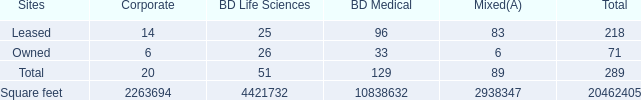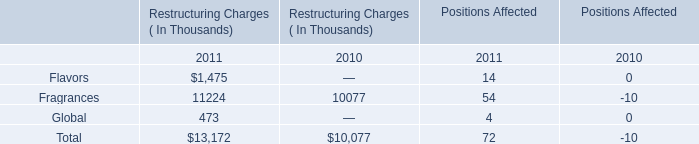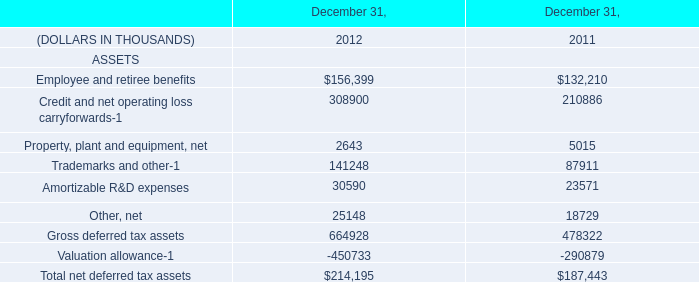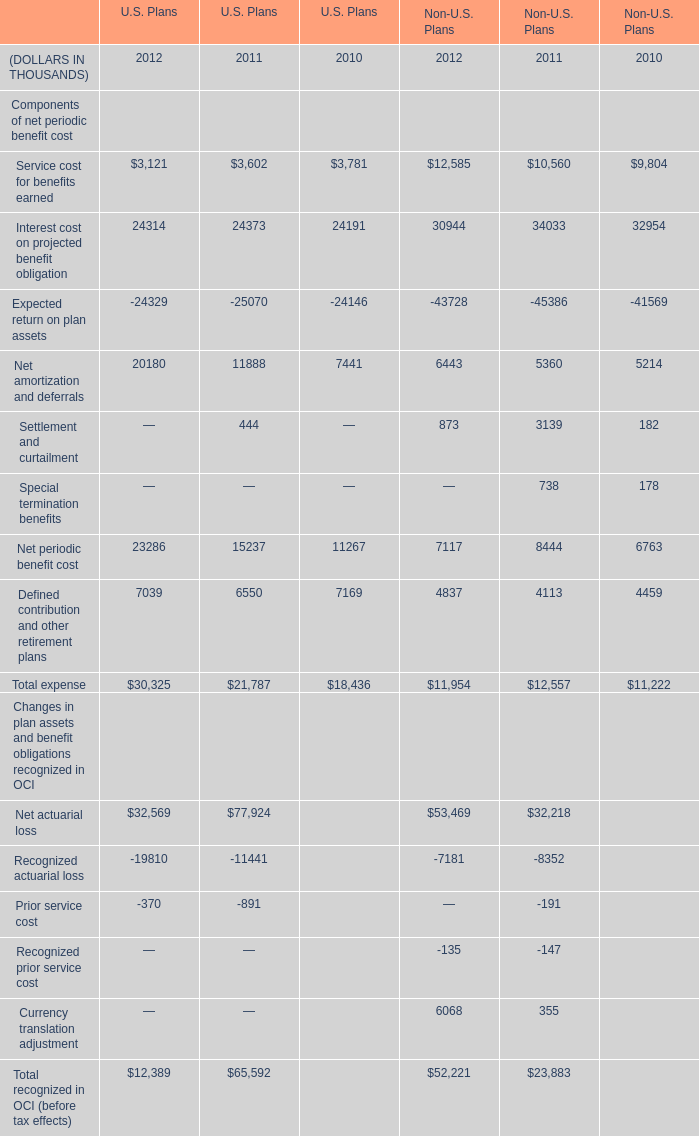What's the average of Square feet of BD Life Sciences, and Net amortization and deferrals of U.S. Plans 2011 ? 
Computations: ((4421732.0 + 11888.0) / 2)
Answer: 2216810.0. 